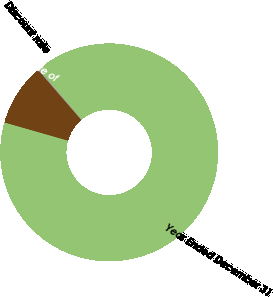Convert chart. <chart><loc_0><loc_0><loc_500><loc_500><pie_chart><fcel>Year Ended December 31<fcel>Discount rate<fcel>Expected long-term rate of<nl><fcel>90.62%<fcel>0.17%<fcel>9.21%<nl></chart> 